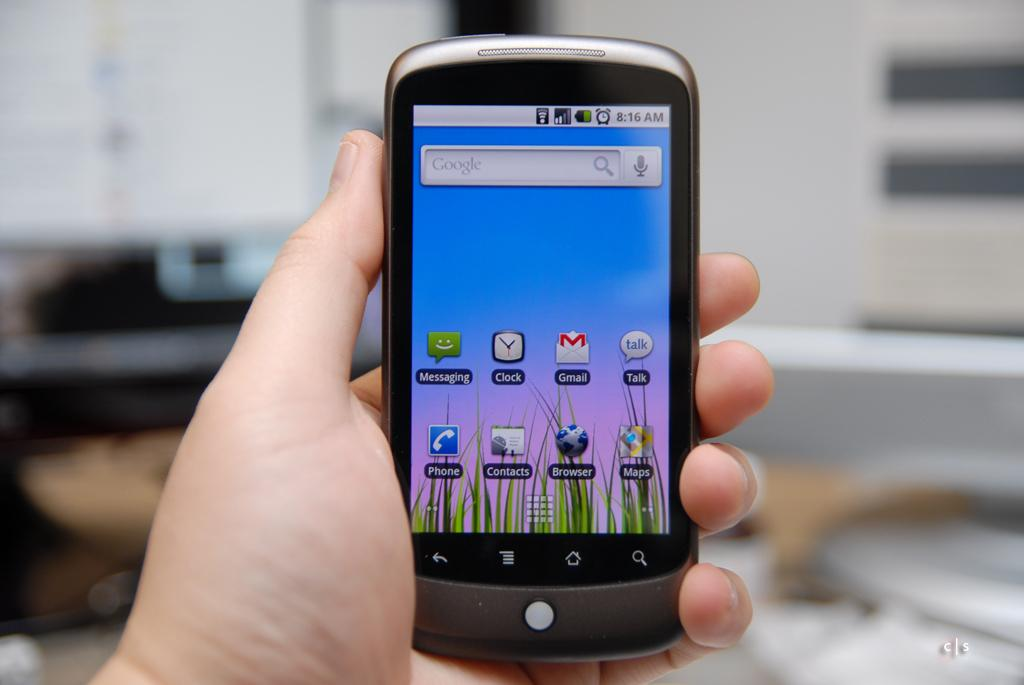<image>
Give a short and clear explanation of the subsequent image. A hand holding a smartphone at 8:16 in the morning 